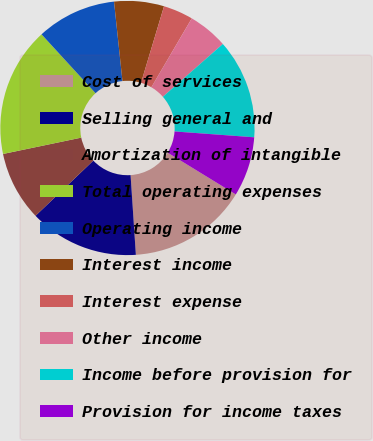<chart> <loc_0><loc_0><loc_500><loc_500><pie_chart><fcel>Cost of services<fcel>Selling general and<fcel>Amortization of intangible<fcel>Total operating expenses<fcel>Operating income<fcel>Interest income<fcel>Interest expense<fcel>Other income<fcel>Income before provision for<fcel>Provision for income taxes<nl><fcel>15.19%<fcel>13.92%<fcel>8.86%<fcel>16.46%<fcel>10.13%<fcel>6.33%<fcel>3.8%<fcel>5.06%<fcel>12.66%<fcel>7.59%<nl></chart> 